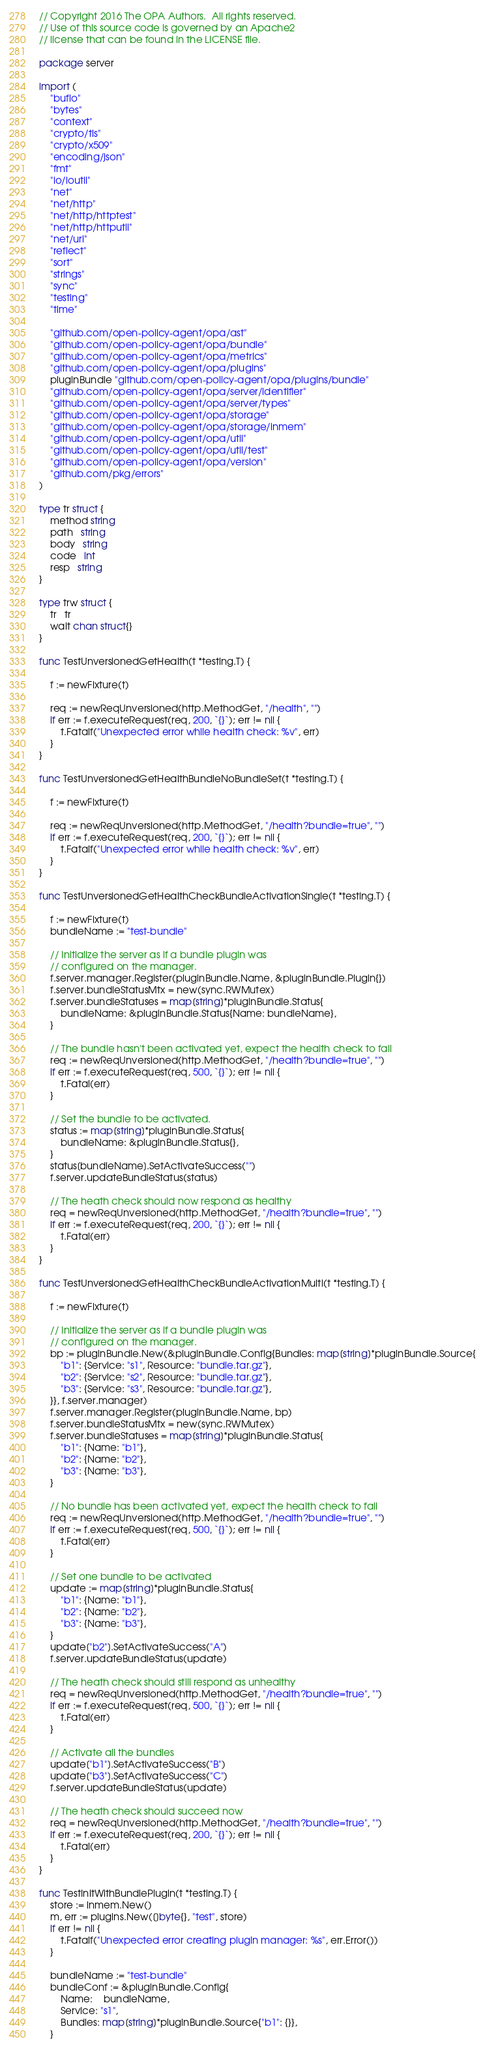<code> <loc_0><loc_0><loc_500><loc_500><_Go_>// Copyright 2016 The OPA Authors.  All rights reserved.
// Use of this source code is governed by an Apache2
// license that can be found in the LICENSE file.

package server

import (
	"bufio"
	"bytes"
	"context"
	"crypto/tls"
	"crypto/x509"
	"encoding/json"
	"fmt"
	"io/ioutil"
	"net"
	"net/http"
	"net/http/httptest"
	"net/http/httputil"
	"net/url"
	"reflect"
	"sort"
	"strings"
	"sync"
	"testing"
	"time"

	"github.com/open-policy-agent/opa/ast"
	"github.com/open-policy-agent/opa/bundle"
	"github.com/open-policy-agent/opa/metrics"
	"github.com/open-policy-agent/opa/plugins"
	pluginBundle "github.com/open-policy-agent/opa/plugins/bundle"
	"github.com/open-policy-agent/opa/server/identifier"
	"github.com/open-policy-agent/opa/server/types"
	"github.com/open-policy-agent/opa/storage"
	"github.com/open-policy-agent/opa/storage/inmem"
	"github.com/open-policy-agent/opa/util"
	"github.com/open-policy-agent/opa/util/test"
	"github.com/open-policy-agent/opa/version"
	"github.com/pkg/errors"
)

type tr struct {
	method string
	path   string
	body   string
	code   int
	resp   string
}

type trw struct {
	tr   tr
	wait chan struct{}
}

func TestUnversionedGetHealth(t *testing.T) {

	f := newFixture(t)

	req := newReqUnversioned(http.MethodGet, "/health", "")
	if err := f.executeRequest(req, 200, `{}`); err != nil {
		t.Fatalf("Unexpected error while health check: %v", err)
	}
}

func TestUnversionedGetHealthBundleNoBundleSet(t *testing.T) {

	f := newFixture(t)

	req := newReqUnversioned(http.MethodGet, "/health?bundle=true", "")
	if err := f.executeRequest(req, 200, `{}`); err != nil {
		t.Fatalf("Unexpected error while health check: %v", err)
	}
}

func TestUnversionedGetHealthCheckBundleActivationSingle(t *testing.T) {

	f := newFixture(t)
	bundleName := "test-bundle"

	// Initialize the server as if a bundle plugin was
	// configured on the manager.
	f.server.manager.Register(pluginBundle.Name, &pluginBundle.Plugin{})
	f.server.bundleStatusMtx = new(sync.RWMutex)
	f.server.bundleStatuses = map[string]*pluginBundle.Status{
		bundleName: &pluginBundle.Status{Name: bundleName},
	}

	// The bundle hasn't been activated yet, expect the health check to fail
	req := newReqUnversioned(http.MethodGet, "/health?bundle=true", "")
	if err := f.executeRequest(req, 500, `{}`); err != nil {
		t.Fatal(err)
	}

	// Set the bundle to be activated.
	status := map[string]*pluginBundle.Status{
		bundleName: &pluginBundle.Status{},
	}
	status[bundleName].SetActivateSuccess("")
	f.server.updateBundleStatus(status)

	// The heath check should now respond as healthy
	req = newReqUnversioned(http.MethodGet, "/health?bundle=true", "")
	if err := f.executeRequest(req, 200, `{}`); err != nil {
		t.Fatal(err)
	}
}

func TestUnversionedGetHealthCheckBundleActivationMulti(t *testing.T) {

	f := newFixture(t)

	// Initialize the server as if a bundle plugin was
	// configured on the manager.
	bp := pluginBundle.New(&pluginBundle.Config{Bundles: map[string]*pluginBundle.Source{
		"b1": {Service: "s1", Resource: "bundle.tar.gz"},
		"b2": {Service: "s2", Resource: "bundle.tar.gz"},
		"b3": {Service: "s3", Resource: "bundle.tar.gz"},
	}}, f.server.manager)
	f.server.manager.Register(pluginBundle.Name, bp)
	f.server.bundleStatusMtx = new(sync.RWMutex)
	f.server.bundleStatuses = map[string]*pluginBundle.Status{
		"b1": {Name: "b1"},
		"b2": {Name: "b2"},
		"b3": {Name: "b3"},
	}

	// No bundle has been activated yet, expect the health check to fail
	req := newReqUnversioned(http.MethodGet, "/health?bundle=true", "")
	if err := f.executeRequest(req, 500, `{}`); err != nil {
		t.Fatal(err)
	}

	// Set one bundle to be activated
	update := map[string]*pluginBundle.Status{
		"b1": {Name: "b1"},
		"b2": {Name: "b2"},
		"b3": {Name: "b3"},
	}
	update["b2"].SetActivateSuccess("A")
	f.server.updateBundleStatus(update)

	// The heath check should still respond as unhealthy
	req = newReqUnversioned(http.MethodGet, "/health?bundle=true", "")
	if err := f.executeRequest(req, 500, `{}`); err != nil {
		t.Fatal(err)
	}

	// Activate all the bundles
	update["b1"].SetActivateSuccess("B")
	update["b3"].SetActivateSuccess("C")
	f.server.updateBundleStatus(update)

	// The heath check should succeed now
	req = newReqUnversioned(http.MethodGet, "/health?bundle=true", "")
	if err := f.executeRequest(req, 200, `{}`); err != nil {
		t.Fatal(err)
	}
}

func TestInitWithBundlePlugin(t *testing.T) {
	store := inmem.New()
	m, err := plugins.New([]byte{}, "test", store)
	if err != nil {
		t.Fatalf("Unexpected error creating plugin manager: %s", err.Error())
	}

	bundleName := "test-bundle"
	bundleConf := &pluginBundle.Config{
		Name:    bundleName,
		Service: "s1",
		Bundles: map[string]*pluginBundle.Source{"b1": {}},
	}
</code> 